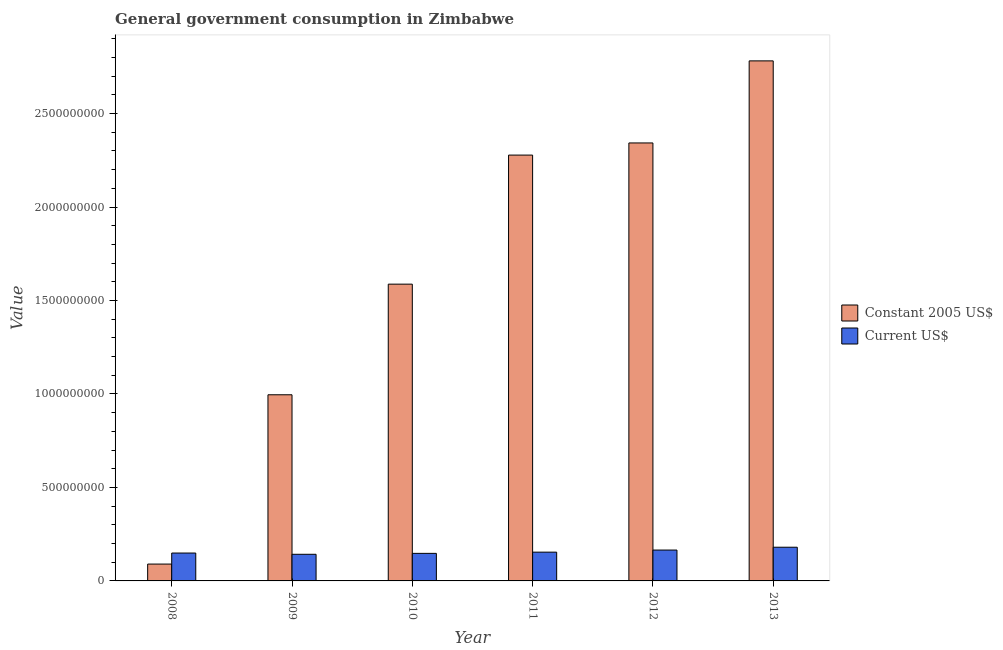Are the number of bars per tick equal to the number of legend labels?
Your response must be concise. Yes. Are the number of bars on each tick of the X-axis equal?
Provide a succinct answer. Yes. How many bars are there on the 2nd tick from the left?
Provide a succinct answer. 2. What is the value consumed in current us$ in 2009?
Offer a terse response. 1.42e+08. Across all years, what is the maximum value consumed in current us$?
Offer a very short reply. 1.80e+08. Across all years, what is the minimum value consumed in current us$?
Your answer should be very brief. 1.42e+08. In which year was the value consumed in current us$ maximum?
Offer a very short reply. 2013. What is the total value consumed in constant 2005 us$ in the graph?
Provide a succinct answer. 1.01e+1. What is the difference between the value consumed in current us$ in 2010 and that in 2011?
Offer a very short reply. -6.57e+06. What is the difference between the value consumed in current us$ in 2012 and the value consumed in constant 2005 us$ in 2008?
Your answer should be compact. 1.59e+07. What is the average value consumed in constant 2005 us$ per year?
Keep it short and to the point. 1.68e+09. In the year 2009, what is the difference between the value consumed in current us$ and value consumed in constant 2005 us$?
Offer a terse response. 0. In how many years, is the value consumed in current us$ greater than 1800000000?
Make the answer very short. 0. What is the ratio of the value consumed in constant 2005 us$ in 2010 to that in 2011?
Your response must be concise. 0.7. What is the difference between the highest and the second highest value consumed in current us$?
Make the answer very short. 1.51e+07. What is the difference between the highest and the lowest value consumed in constant 2005 us$?
Your answer should be compact. 2.69e+09. In how many years, is the value consumed in constant 2005 us$ greater than the average value consumed in constant 2005 us$ taken over all years?
Your answer should be compact. 3. What does the 2nd bar from the left in 2012 represents?
Provide a short and direct response. Current US$. What does the 1st bar from the right in 2013 represents?
Give a very brief answer. Current US$. How many bars are there?
Offer a terse response. 12. Are all the bars in the graph horizontal?
Your answer should be compact. No. What is the difference between two consecutive major ticks on the Y-axis?
Provide a succinct answer. 5.00e+08. Does the graph contain grids?
Your answer should be compact. No. Where does the legend appear in the graph?
Offer a very short reply. Center right. How many legend labels are there?
Ensure brevity in your answer.  2. What is the title of the graph?
Offer a terse response. General government consumption in Zimbabwe. What is the label or title of the Y-axis?
Provide a succinct answer. Value. What is the Value in Constant 2005 US$ in 2008?
Provide a short and direct response. 9.01e+07. What is the Value in Current US$ in 2008?
Offer a very short reply. 1.49e+08. What is the Value in Constant 2005 US$ in 2009?
Keep it short and to the point. 9.96e+08. What is the Value in Current US$ in 2009?
Offer a very short reply. 1.42e+08. What is the Value in Constant 2005 US$ in 2010?
Keep it short and to the point. 1.59e+09. What is the Value in Current US$ in 2010?
Offer a terse response. 1.47e+08. What is the Value in Constant 2005 US$ in 2011?
Give a very brief answer. 2.28e+09. What is the Value of Current US$ in 2011?
Your response must be concise. 1.54e+08. What is the Value in Constant 2005 US$ in 2012?
Make the answer very short. 2.34e+09. What is the Value in Current US$ in 2012?
Your response must be concise. 1.65e+08. What is the Value of Constant 2005 US$ in 2013?
Ensure brevity in your answer.  2.78e+09. What is the Value of Current US$ in 2013?
Offer a terse response. 1.80e+08. Across all years, what is the maximum Value in Constant 2005 US$?
Keep it short and to the point. 2.78e+09. Across all years, what is the maximum Value in Current US$?
Your answer should be compact. 1.80e+08. Across all years, what is the minimum Value of Constant 2005 US$?
Your answer should be very brief. 9.01e+07. Across all years, what is the minimum Value of Current US$?
Keep it short and to the point. 1.42e+08. What is the total Value in Constant 2005 US$ in the graph?
Give a very brief answer. 1.01e+1. What is the total Value in Current US$ in the graph?
Make the answer very short. 9.38e+08. What is the difference between the Value in Constant 2005 US$ in 2008 and that in 2009?
Keep it short and to the point. -9.06e+08. What is the difference between the Value of Current US$ in 2008 and that in 2009?
Offer a very short reply. 6.74e+06. What is the difference between the Value in Constant 2005 US$ in 2008 and that in 2010?
Keep it short and to the point. -1.50e+09. What is the difference between the Value of Current US$ in 2008 and that in 2010?
Give a very brief answer. 1.81e+06. What is the difference between the Value of Constant 2005 US$ in 2008 and that in 2011?
Provide a short and direct response. -2.19e+09. What is the difference between the Value of Current US$ in 2008 and that in 2011?
Your answer should be compact. -4.76e+06. What is the difference between the Value of Constant 2005 US$ in 2008 and that in 2012?
Ensure brevity in your answer.  -2.25e+09. What is the difference between the Value in Current US$ in 2008 and that in 2012?
Give a very brief answer. -1.59e+07. What is the difference between the Value of Constant 2005 US$ in 2008 and that in 2013?
Provide a short and direct response. -2.69e+09. What is the difference between the Value of Current US$ in 2008 and that in 2013?
Provide a short and direct response. -3.11e+07. What is the difference between the Value in Constant 2005 US$ in 2009 and that in 2010?
Offer a very short reply. -5.92e+08. What is the difference between the Value in Current US$ in 2009 and that in 2010?
Keep it short and to the point. -4.93e+06. What is the difference between the Value in Constant 2005 US$ in 2009 and that in 2011?
Offer a very short reply. -1.28e+09. What is the difference between the Value in Current US$ in 2009 and that in 2011?
Ensure brevity in your answer.  -1.15e+07. What is the difference between the Value of Constant 2005 US$ in 2009 and that in 2012?
Offer a very short reply. -1.35e+09. What is the difference between the Value of Current US$ in 2009 and that in 2012?
Offer a very short reply. -2.27e+07. What is the difference between the Value in Constant 2005 US$ in 2009 and that in 2013?
Make the answer very short. -1.79e+09. What is the difference between the Value of Current US$ in 2009 and that in 2013?
Offer a very short reply. -3.78e+07. What is the difference between the Value of Constant 2005 US$ in 2010 and that in 2011?
Offer a terse response. -6.90e+08. What is the difference between the Value in Current US$ in 2010 and that in 2011?
Make the answer very short. -6.57e+06. What is the difference between the Value in Constant 2005 US$ in 2010 and that in 2012?
Provide a short and direct response. -7.55e+08. What is the difference between the Value in Current US$ in 2010 and that in 2012?
Provide a succinct answer. -1.77e+07. What is the difference between the Value in Constant 2005 US$ in 2010 and that in 2013?
Offer a very short reply. -1.19e+09. What is the difference between the Value in Current US$ in 2010 and that in 2013?
Provide a short and direct response. -3.29e+07. What is the difference between the Value of Constant 2005 US$ in 2011 and that in 2012?
Your answer should be compact. -6.49e+07. What is the difference between the Value of Current US$ in 2011 and that in 2012?
Give a very brief answer. -1.12e+07. What is the difference between the Value of Constant 2005 US$ in 2011 and that in 2013?
Your response must be concise. -5.04e+08. What is the difference between the Value in Current US$ in 2011 and that in 2013?
Ensure brevity in your answer.  -2.63e+07. What is the difference between the Value in Constant 2005 US$ in 2012 and that in 2013?
Your answer should be compact. -4.39e+08. What is the difference between the Value of Current US$ in 2012 and that in 2013?
Offer a very short reply. -1.51e+07. What is the difference between the Value of Constant 2005 US$ in 2008 and the Value of Current US$ in 2009?
Make the answer very short. -5.23e+07. What is the difference between the Value in Constant 2005 US$ in 2008 and the Value in Current US$ in 2010?
Offer a very short reply. -5.72e+07. What is the difference between the Value of Constant 2005 US$ in 2008 and the Value of Current US$ in 2011?
Offer a terse response. -6.38e+07. What is the difference between the Value in Constant 2005 US$ in 2008 and the Value in Current US$ in 2012?
Make the answer very short. -7.50e+07. What is the difference between the Value of Constant 2005 US$ in 2008 and the Value of Current US$ in 2013?
Give a very brief answer. -9.01e+07. What is the difference between the Value in Constant 2005 US$ in 2009 and the Value in Current US$ in 2010?
Your response must be concise. 8.48e+08. What is the difference between the Value of Constant 2005 US$ in 2009 and the Value of Current US$ in 2011?
Your answer should be very brief. 8.42e+08. What is the difference between the Value in Constant 2005 US$ in 2009 and the Value in Current US$ in 2012?
Give a very brief answer. 8.31e+08. What is the difference between the Value in Constant 2005 US$ in 2009 and the Value in Current US$ in 2013?
Your response must be concise. 8.15e+08. What is the difference between the Value in Constant 2005 US$ in 2010 and the Value in Current US$ in 2011?
Your answer should be compact. 1.43e+09. What is the difference between the Value of Constant 2005 US$ in 2010 and the Value of Current US$ in 2012?
Give a very brief answer. 1.42e+09. What is the difference between the Value of Constant 2005 US$ in 2010 and the Value of Current US$ in 2013?
Keep it short and to the point. 1.41e+09. What is the difference between the Value in Constant 2005 US$ in 2011 and the Value in Current US$ in 2012?
Make the answer very short. 2.11e+09. What is the difference between the Value in Constant 2005 US$ in 2011 and the Value in Current US$ in 2013?
Make the answer very short. 2.10e+09. What is the difference between the Value of Constant 2005 US$ in 2012 and the Value of Current US$ in 2013?
Offer a very short reply. 2.16e+09. What is the average Value of Constant 2005 US$ per year?
Keep it short and to the point. 1.68e+09. What is the average Value in Current US$ per year?
Provide a short and direct response. 1.56e+08. In the year 2008, what is the difference between the Value in Constant 2005 US$ and Value in Current US$?
Your answer should be very brief. -5.90e+07. In the year 2009, what is the difference between the Value in Constant 2005 US$ and Value in Current US$?
Make the answer very short. 8.53e+08. In the year 2010, what is the difference between the Value of Constant 2005 US$ and Value of Current US$?
Keep it short and to the point. 1.44e+09. In the year 2011, what is the difference between the Value of Constant 2005 US$ and Value of Current US$?
Provide a succinct answer. 2.12e+09. In the year 2012, what is the difference between the Value of Constant 2005 US$ and Value of Current US$?
Keep it short and to the point. 2.18e+09. In the year 2013, what is the difference between the Value of Constant 2005 US$ and Value of Current US$?
Offer a terse response. 2.60e+09. What is the ratio of the Value of Constant 2005 US$ in 2008 to that in 2009?
Offer a terse response. 0.09. What is the ratio of the Value in Current US$ in 2008 to that in 2009?
Make the answer very short. 1.05. What is the ratio of the Value of Constant 2005 US$ in 2008 to that in 2010?
Your answer should be compact. 0.06. What is the ratio of the Value of Current US$ in 2008 to that in 2010?
Offer a very short reply. 1.01. What is the ratio of the Value of Constant 2005 US$ in 2008 to that in 2011?
Keep it short and to the point. 0.04. What is the ratio of the Value of Current US$ in 2008 to that in 2011?
Your answer should be compact. 0.97. What is the ratio of the Value in Constant 2005 US$ in 2008 to that in 2012?
Your answer should be compact. 0.04. What is the ratio of the Value of Current US$ in 2008 to that in 2012?
Offer a terse response. 0.9. What is the ratio of the Value of Constant 2005 US$ in 2008 to that in 2013?
Make the answer very short. 0.03. What is the ratio of the Value in Current US$ in 2008 to that in 2013?
Keep it short and to the point. 0.83. What is the ratio of the Value of Constant 2005 US$ in 2009 to that in 2010?
Give a very brief answer. 0.63. What is the ratio of the Value in Current US$ in 2009 to that in 2010?
Ensure brevity in your answer.  0.97. What is the ratio of the Value of Constant 2005 US$ in 2009 to that in 2011?
Your answer should be compact. 0.44. What is the ratio of the Value in Current US$ in 2009 to that in 2011?
Your answer should be compact. 0.93. What is the ratio of the Value of Constant 2005 US$ in 2009 to that in 2012?
Your answer should be compact. 0.42. What is the ratio of the Value of Current US$ in 2009 to that in 2012?
Your answer should be very brief. 0.86. What is the ratio of the Value of Constant 2005 US$ in 2009 to that in 2013?
Offer a terse response. 0.36. What is the ratio of the Value of Current US$ in 2009 to that in 2013?
Give a very brief answer. 0.79. What is the ratio of the Value in Constant 2005 US$ in 2010 to that in 2011?
Your response must be concise. 0.7. What is the ratio of the Value in Current US$ in 2010 to that in 2011?
Your response must be concise. 0.96. What is the ratio of the Value in Constant 2005 US$ in 2010 to that in 2012?
Your answer should be compact. 0.68. What is the ratio of the Value in Current US$ in 2010 to that in 2012?
Your response must be concise. 0.89. What is the ratio of the Value in Constant 2005 US$ in 2010 to that in 2013?
Provide a succinct answer. 0.57. What is the ratio of the Value in Current US$ in 2010 to that in 2013?
Offer a terse response. 0.82. What is the ratio of the Value of Constant 2005 US$ in 2011 to that in 2012?
Ensure brevity in your answer.  0.97. What is the ratio of the Value in Current US$ in 2011 to that in 2012?
Your answer should be very brief. 0.93. What is the ratio of the Value in Constant 2005 US$ in 2011 to that in 2013?
Provide a succinct answer. 0.82. What is the ratio of the Value in Current US$ in 2011 to that in 2013?
Give a very brief answer. 0.85. What is the ratio of the Value in Constant 2005 US$ in 2012 to that in 2013?
Offer a very short reply. 0.84. What is the ratio of the Value of Current US$ in 2012 to that in 2013?
Provide a short and direct response. 0.92. What is the difference between the highest and the second highest Value of Constant 2005 US$?
Offer a very short reply. 4.39e+08. What is the difference between the highest and the second highest Value in Current US$?
Provide a succinct answer. 1.51e+07. What is the difference between the highest and the lowest Value in Constant 2005 US$?
Make the answer very short. 2.69e+09. What is the difference between the highest and the lowest Value of Current US$?
Offer a very short reply. 3.78e+07. 